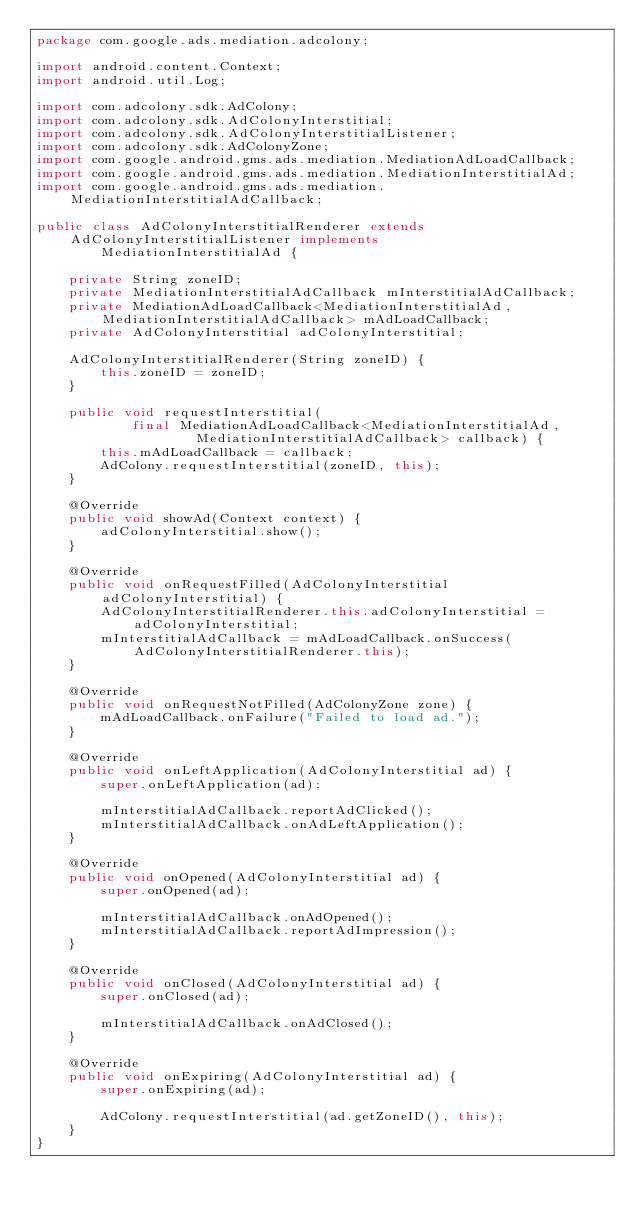<code> <loc_0><loc_0><loc_500><loc_500><_Java_>package com.google.ads.mediation.adcolony;

import android.content.Context;
import android.util.Log;

import com.adcolony.sdk.AdColony;
import com.adcolony.sdk.AdColonyInterstitial;
import com.adcolony.sdk.AdColonyInterstitialListener;
import com.adcolony.sdk.AdColonyZone;
import com.google.android.gms.ads.mediation.MediationAdLoadCallback;
import com.google.android.gms.ads.mediation.MediationInterstitialAd;
import com.google.android.gms.ads.mediation.MediationInterstitialAdCallback;

public class AdColonyInterstitialRenderer extends AdColonyInterstitialListener implements
        MediationInterstitialAd {

    private String zoneID;
    private MediationInterstitialAdCallback mInterstitialAdCallback;
    private MediationAdLoadCallback<MediationInterstitialAd, MediationInterstitialAdCallback> mAdLoadCallback;
    private AdColonyInterstitial adColonyInterstitial;

    AdColonyInterstitialRenderer(String zoneID) {
        this.zoneID = zoneID;
    }

    public void requestInterstitial(
            final MediationAdLoadCallback<MediationInterstitialAd,
                    MediationInterstitialAdCallback> callback) {
        this.mAdLoadCallback = callback;
        AdColony.requestInterstitial(zoneID, this);
    }

    @Override
    public void showAd(Context context) {
        adColonyInterstitial.show();
    }

    @Override
    public void onRequestFilled(AdColonyInterstitial adColonyInterstitial) {
        AdColonyInterstitialRenderer.this.adColonyInterstitial = adColonyInterstitial;
        mInterstitialAdCallback = mAdLoadCallback.onSuccess(AdColonyInterstitialRenderer.this);
    }

    @Override
    public void onRequestNotFilled(AdColonyZone zone) {
        mAdLoadCallback.onFailure("Failed to load ad.");
    }

    @Override
    public void onLeftApplication(AdColonyInterstitial ad) {
        super.onLeftApplication(ad);

        mInterstitialAdCallback.reportAdClicked();
        mInterstitialAdCallback.onAdLeftApplication();
    }

    @Override
    public void onOpened(AdColonyInterstitial ad) {
        super.onOpened(ad);

        mInterstitialAdCallback.onAdOpened();
        mInterstitialAdCallback.reportAdImpression();
    }

    @Override
    public void onClosed(AdColonyInterstitial ad) {
        super.onClosed(ad);

        mInterstitialAdCallback.onAdClosed();
    }

    @Override
    public void onExpiring(AdColonyInterstitial ad) {
        super.onExpiring(ad);

        AdColony.requestInterstitial(ad.getZoneID(), this);
    }
}

</code> 